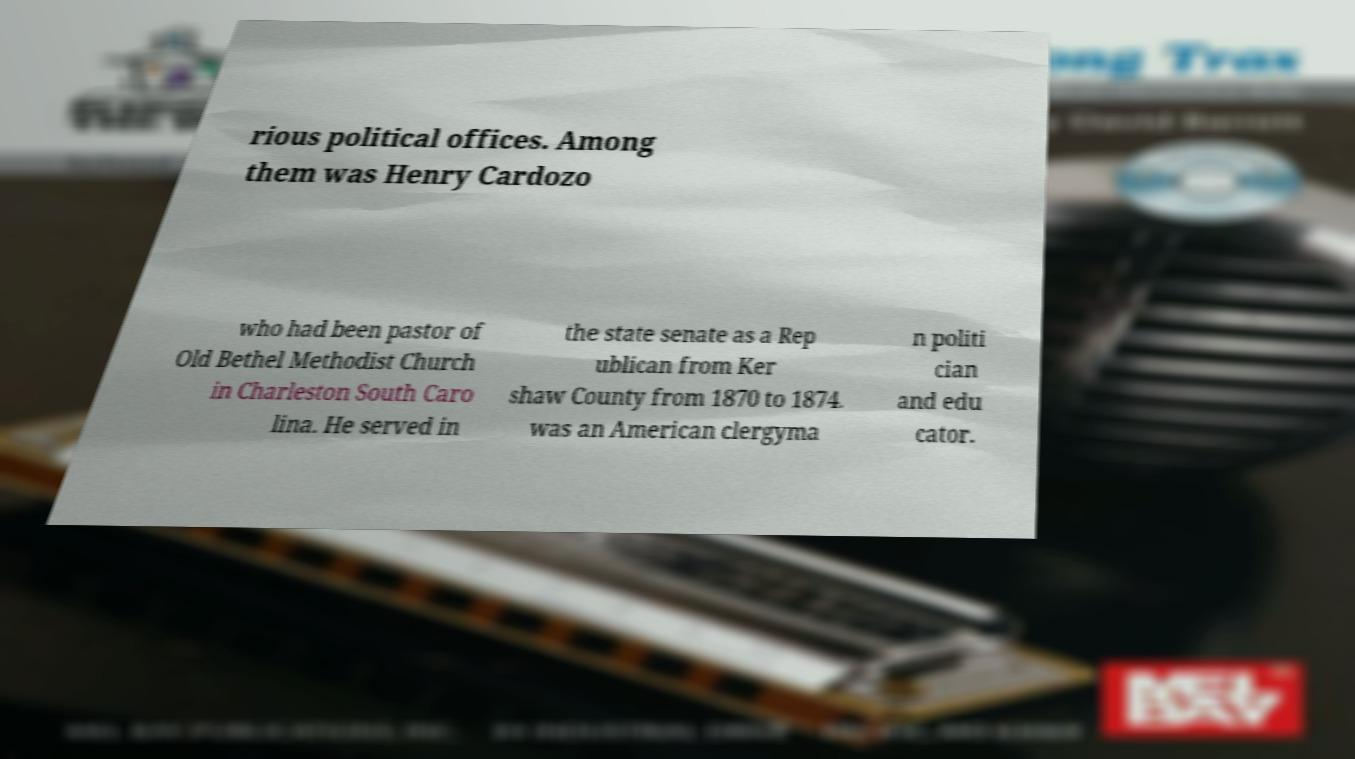What messages or text are displayed in this image? I need them in a readable, typed format. rious political offices. Among them was Henry Cardozo who had been pastor of Old Bethel Methodist Church in Charleston South Caro lina. He served in the state senate as a Rep ublican from Ker shaw County from 1870 to 1874. was an American clergyma n politi cian and edu cator. 